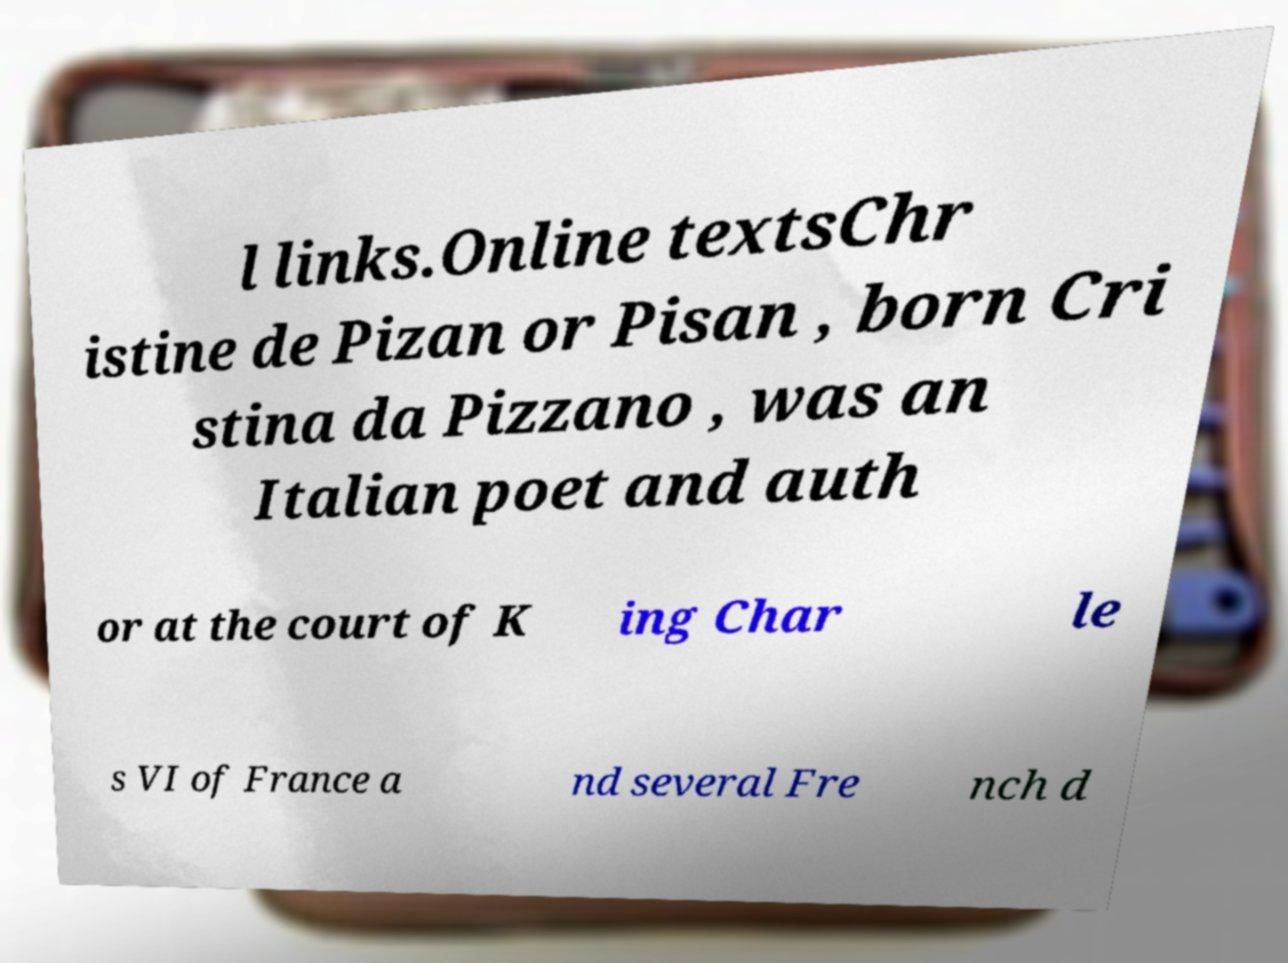I need the written content from this picture converted into text. Can you do that? l links.Online textsChr istine de Pizan or Pisan , born Cri stina da Pizzano , was an Italian poet and auth or at the court of K ing Char le s VI of France a nd several Fre nch d 